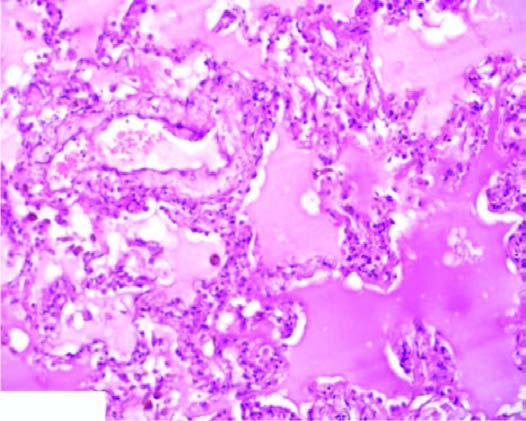re the alveolar capillaries congested?
Answer the question using a single word or phrase. Yes 